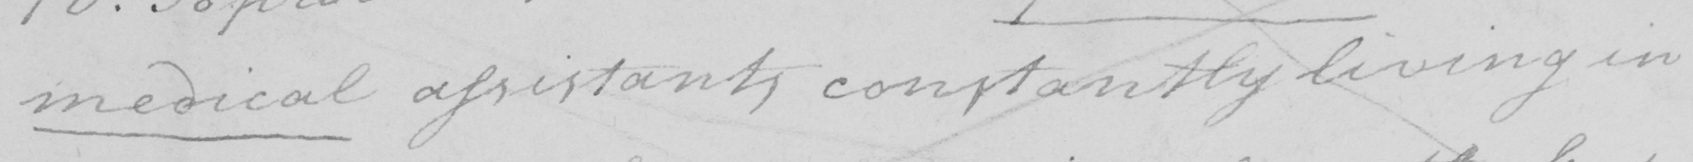Transcribe the text shown in this historical manuscript line. medical assistants constantly living in 